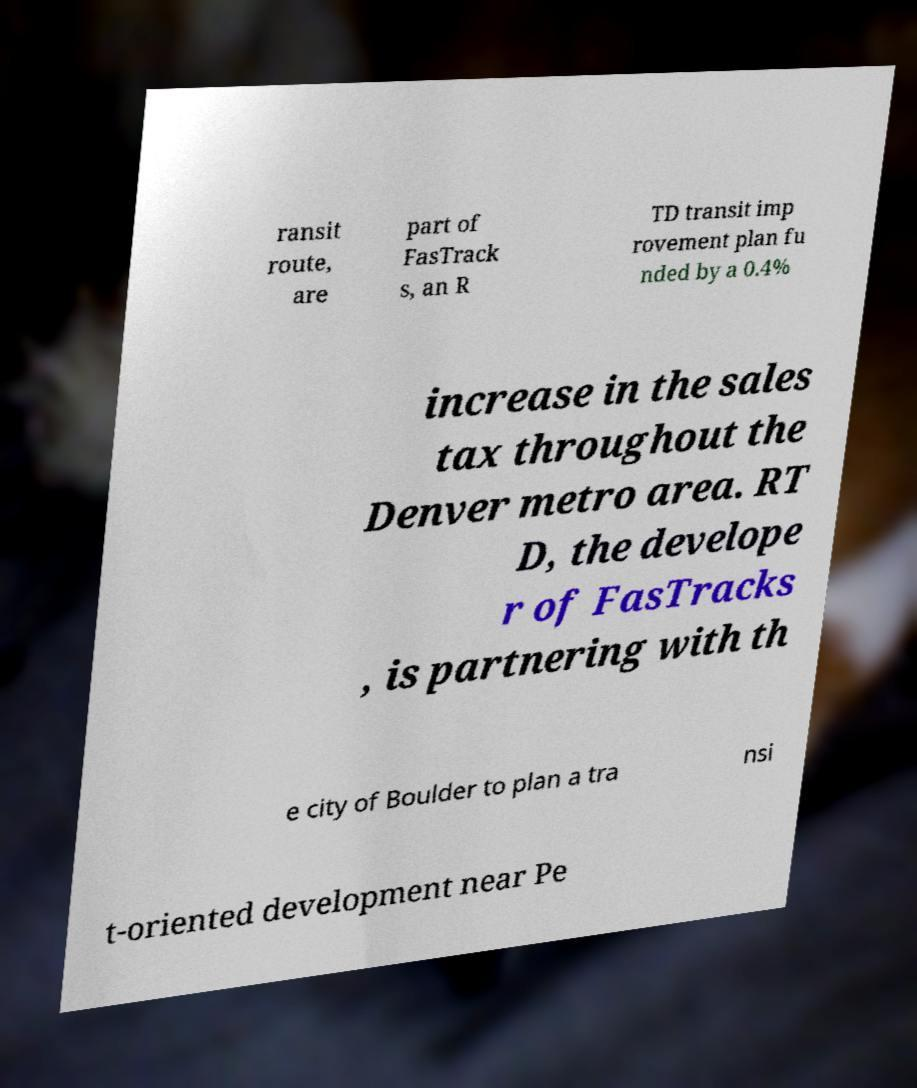What messages or text are displayed in this image? I need them in a readable, typed format. ransit route, are part of FasTrack s, an R TD transit imp rovement plan fu nded by a 0.4% increase in the sales tax throughout the Denver metro area. RT D, the develope r of FasTracks , is partnering with th e city of Boulder to plan a tra nsi t-oriented development near Pe 